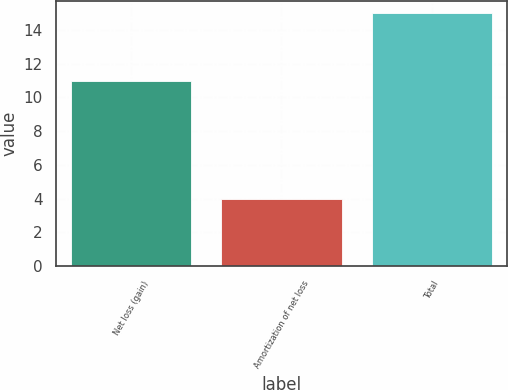Convert chart to OTSL. <chart><loc_0><loc_0><loc_500><loc_500><bar_chart><fcel>Net loss (gain)<fcel>Amortization of net loss<fcel>Total<nl><fcel>11<fcel>4<fcel>15<nl></chart> 